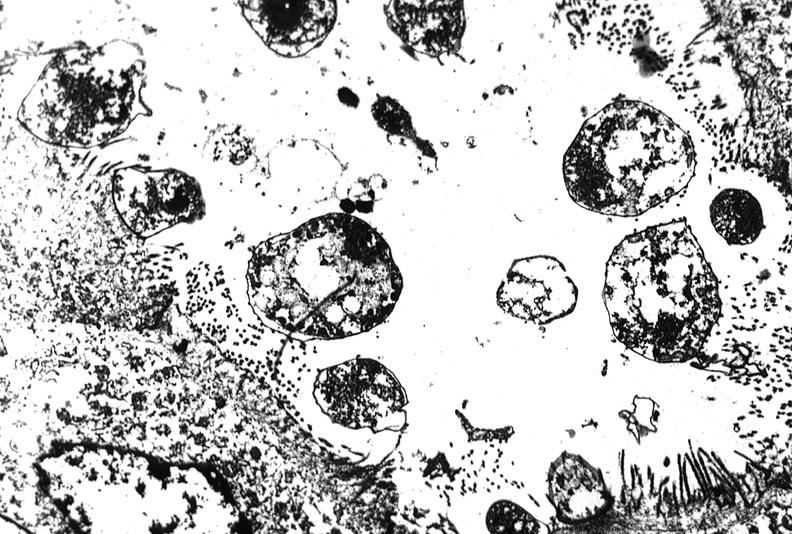where is this electron microscopy figure taken?
Answer the question using a single word or phrase. Gastrointestinal system 